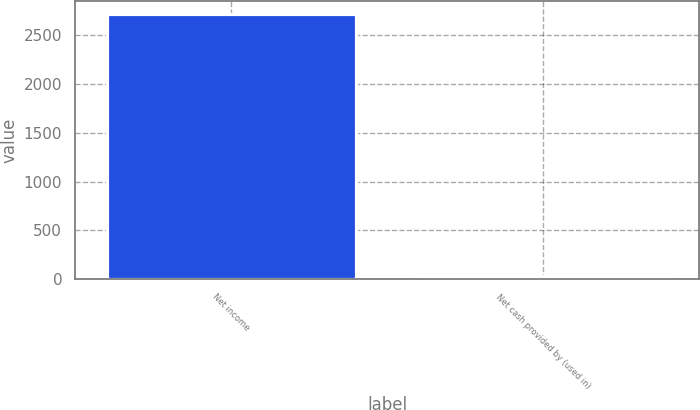Convert chart to OTSL. <chart><loc_0><loc_0><loc_500><loc_500><bar_chart><fcel>Net income<fcel>Net cash provided by (used in)<nl><fcel>2712<fcel>29<nl></chart> 